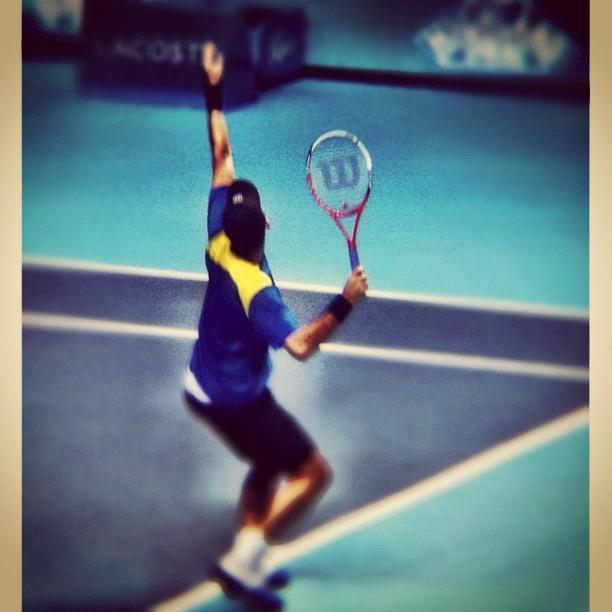How many tennis rackets are in the picture?
Give a very brief answer. 1. 